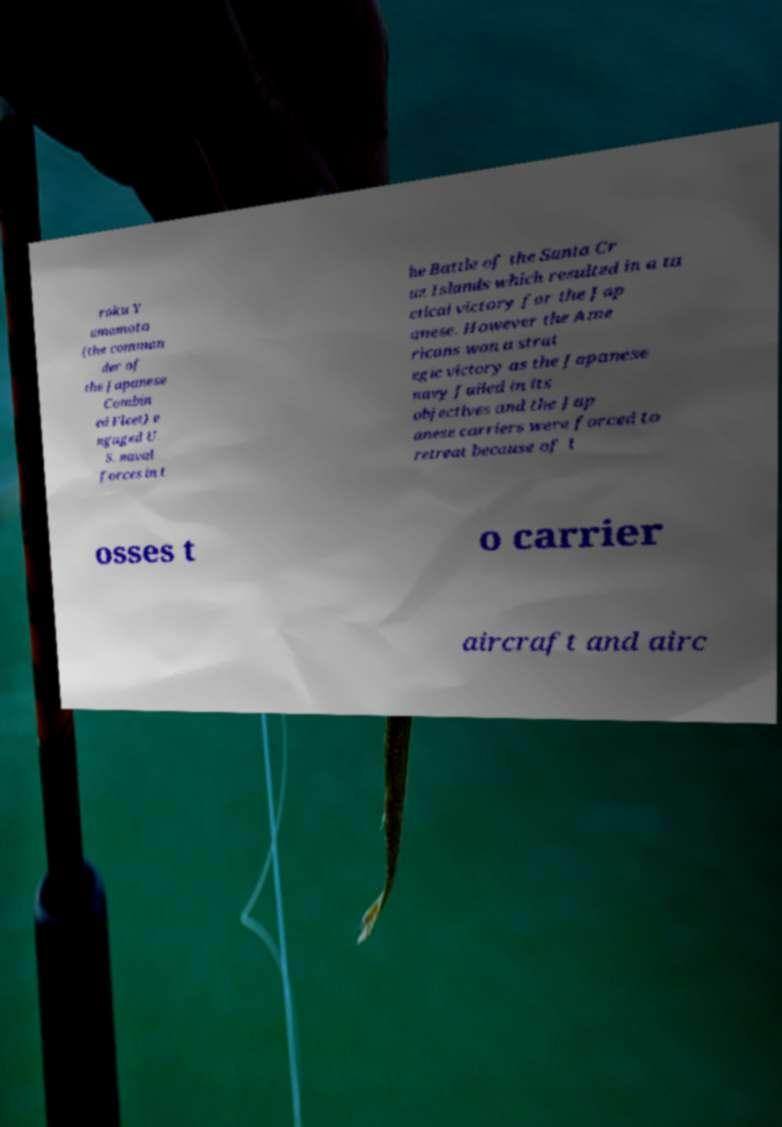Could you assist in decoding the text presented in this image and type it out clearly? roku Y amamoto (the comman der of the Japanese Combin ed Fleet) e ngaged U. S. naval forces in t he Battle of the Santa Cr uz Islands which resulted in a ta ctical victory for the Jap anese. However the Ame ricans won a strat egic victory as the Japanese navy failed in its objectives and the Jap anese carriers were forced to retreat because of l osses t o carrier aircraft and airc 